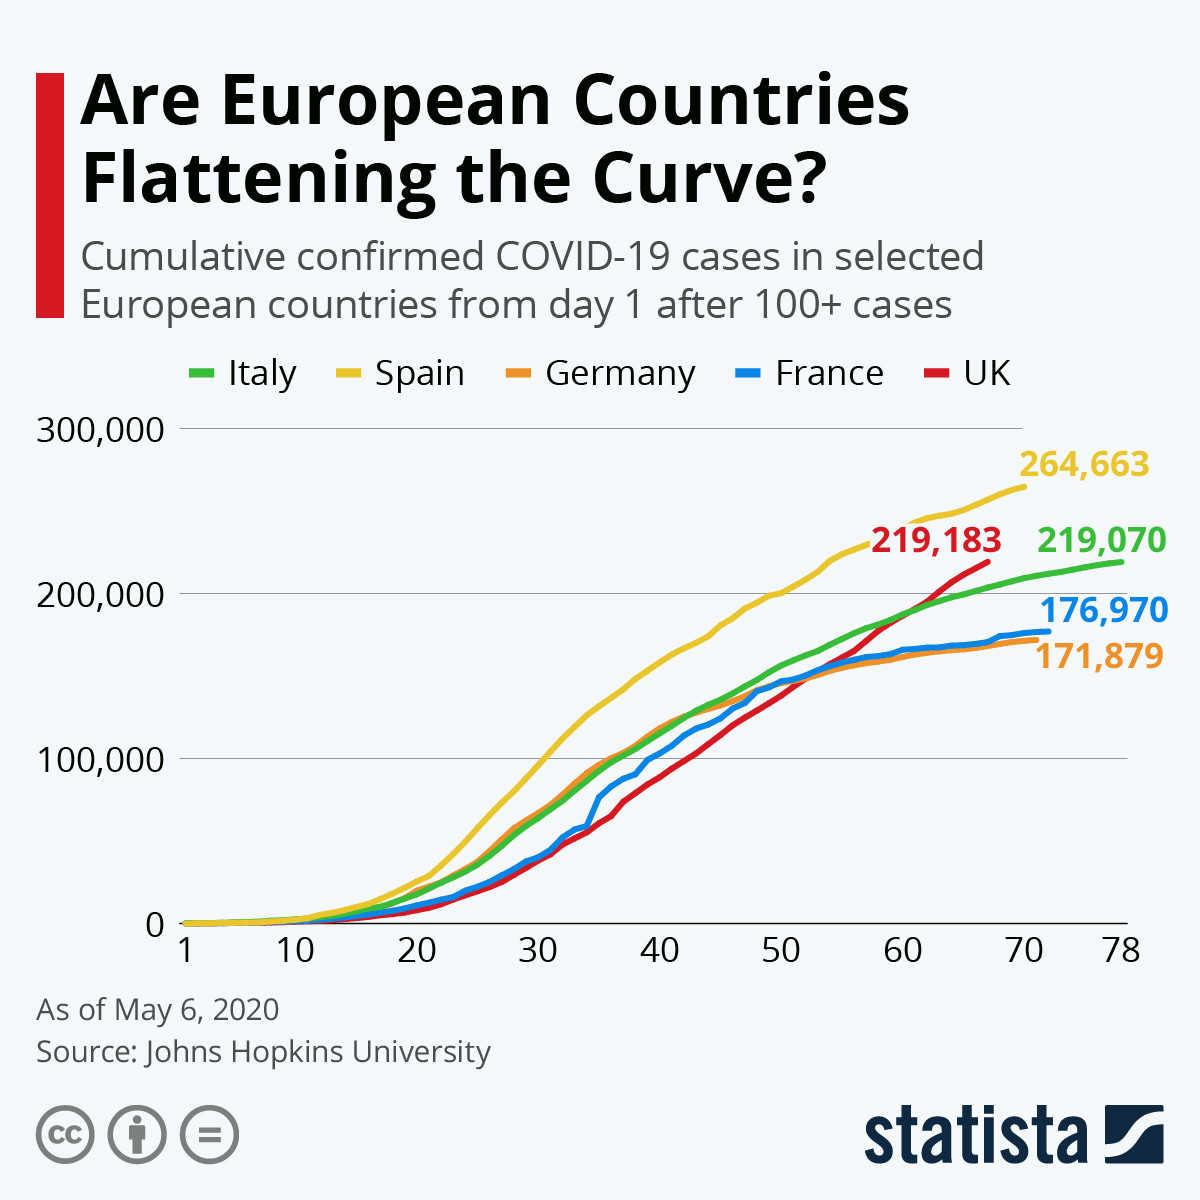Specify some key components in this picture. France and Germany are countries that have had fewer than 200,000 reported COVID-19 cases. There were three countries that had cases above 200,000. The green-colored line represents Italy. Out of the countries with reported cases, how many had a total count below 200,000? Spain has the highest cumulative confirmed cases as of May 6, 2020. 